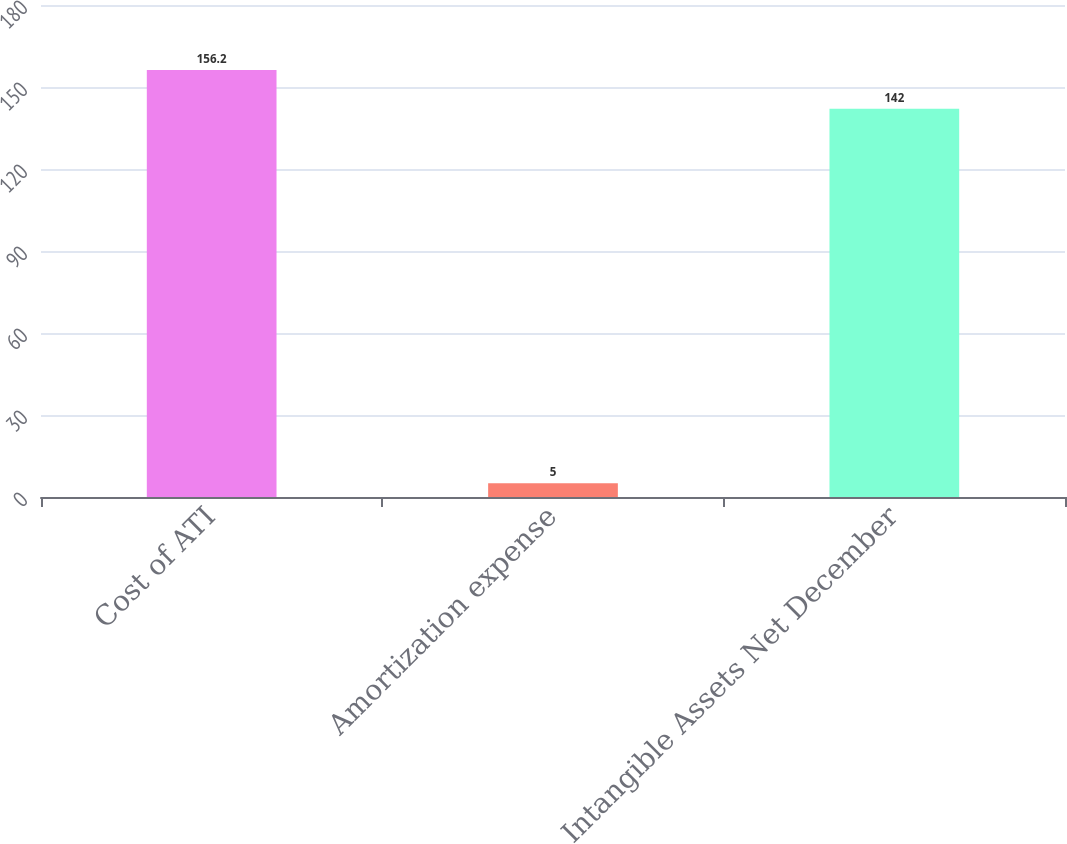Convert chart. <chart><loc_0><loc_0><loc_500><loc_500><bar_chart><fcel>Cost of ATI<fcel>Amortization expense<fcel>Intangible Assets Net December<nl><fcel>156.2<fcel>5<fcel>142<nl></chart> 